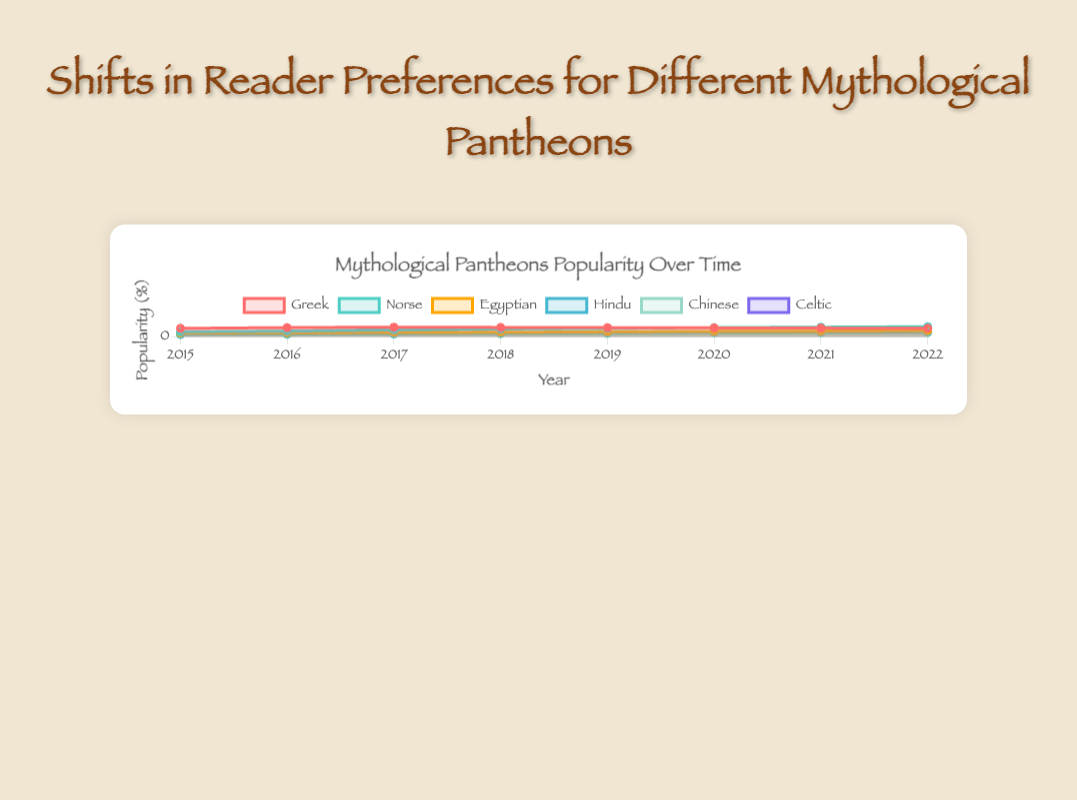What is the overall trend for the popularity of Greek pantheon from 2015 to 2022? The popularity of the Greek pantheon started at 35% in 2015, rose to its peak at 40% in 2017, and then steadily declined to 35% by 2022.
Answer: Started high, peaked, then declined Which pantheon showed the most significant increase in popularity from 2015 to 2022? The Norse pantheon increased from 20% in 2015 to 42% in 2022, a rise of 22 percentage points, which is the largest increase among all pantheons.
Answer: Norse Between 2015 and 2022, which year did the Egyptian pantheon see the highest growth in popularity? The Egyptian pantheon saw the highest growth between 2018 and 2019, increasing from 18% to 20%, a rise of 2 percentage points.
Answer: 2019 Compare the popularity of the Greek and Hindu pantheons in 2022. Which one was more popular? In 2022, the Greek pantheon had a popularity of 35%, while the Hindu pantheon had a popularity of 20%. The Greek pantheon was more popular.
Answer: Greek By how much did the popularity of the Chinese pantheon change from 2015 to 2022? The Chinese pantheon’s popularity grew from 8% in 2015 to 16% in 2022, an increase of 8 percentage points.
Answer: 8 percentage points Which pantheon had the smallest increase in popularity from 2015 to 2022? The Greek pantheon had a popularity of 35% in both 2015 and 2022, indicating no overall increase.
Answer: Greek What is the visual difference between the representations of the Norse and Celtic pantheons on the plot? The Norse pantheon is represented by a line trending strongly upwards, mostly purple in color. The Celtic pantheon trends upwards more gradually and is represented by a greenish line.
Answer: Norse: purple, steep rise; Celtic: greenish, gradual rise During which year does the Hindu pantheon surpass the popularity of the Chinese pantheon for the first time? In 2017, the popularity of the Hindu pantheon (12%) surpassed the Chinese pantheon (10%) for the first time.
Answer: 2017 Calculate the average popularity of the Egyptian pantheon from 2015 to 2022. Sum the values (15, 16, 17, 18, 20, 22, 23, 25) to get 156. Divide by the number of years (8) to get 19.5.
Answer: 19.5 Between which consecutive years did the popularity of the Norse pantheon increase the most? The largest increase occurred between 2017 and 2018, where it rose from 28% to 32%, a gain of 4 percentage points.
Answer: 2017 to 2018 